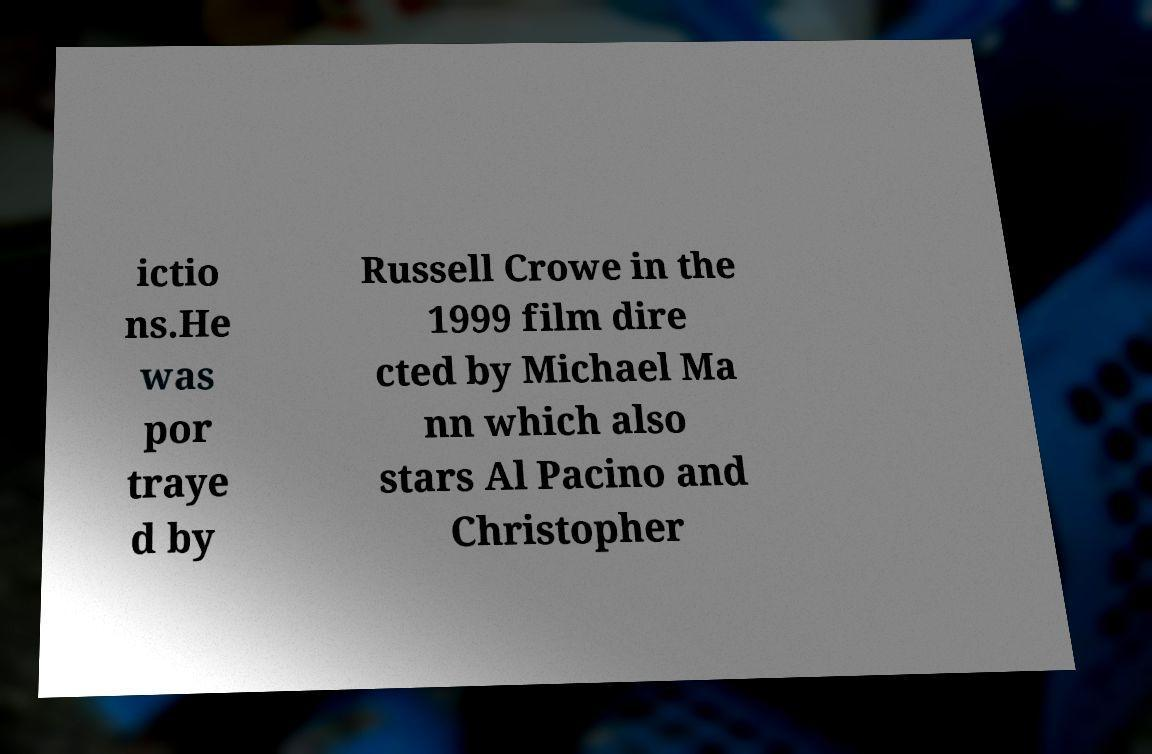Please identify and transcribe the text found in this image. ictio ns.He was por traye d by Russell Crowe in the 1999 film dire cted by Michael Ma nn which also stars Al Pacino and Christopher 